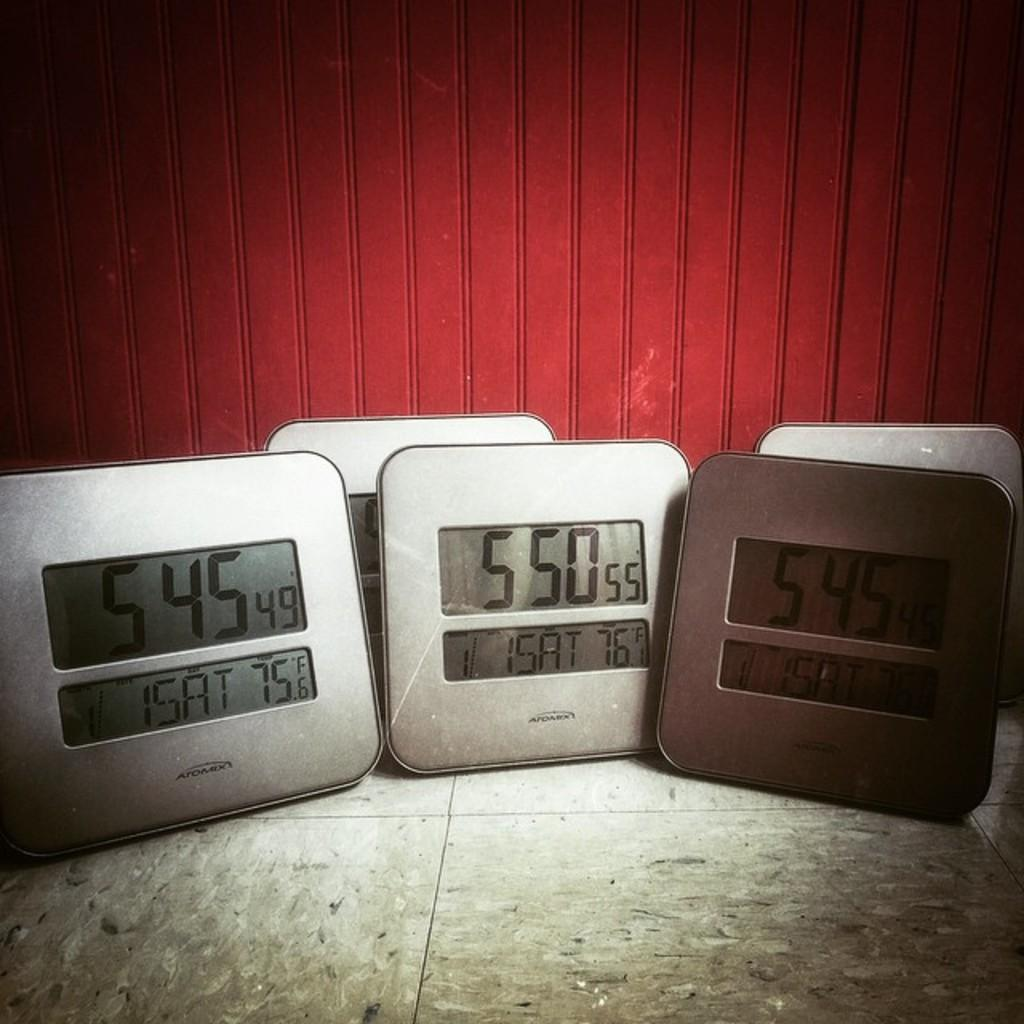<image>
Offer a succinct explanation of the picture presented. three clocks in a row, the middle on reading 5 50 